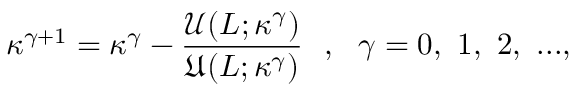<formula> <loc_0><loc_0><loc_500><loc_500>\kappa ^ { \gamma + 1 } = \kappa ^ { \gamma } - \frac { \mathcal { U } ( L ; \kappa ^ { \gamma } ) } { \mathfrak { U } ( L ; \kappa ^ { \gamma } ) } , \gamma = 0 , 1 , 2 , \dots ,</formula> 